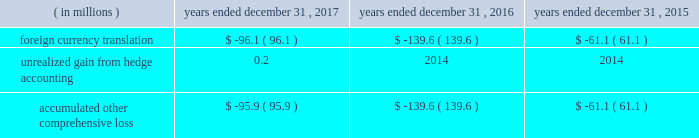Table of contents cdw corporation and subsidiaries method or straight-line method , as applicable .
The company classifies deferred financing costs as a direct deduction from the carrying value of the long-term debt liability on the consolidated balance sheets , except for deferred financing costs associated with revolving credit facilities which are presented as an asset , within other assets on the consolidated balance sheets .
Derivative instruments the company has interest rate cap agreements for the purpose of hedging its exposure to fluctuations in interest rates .
The interest rate cap agreements are designated as cash flow hedges of interest rate risk and recorded at fair value in other assets on the consolidated balance sheets .
The gain or loss on the derivative instruments is reported as a component of accumulated other comprehensive loss until reclassified to interest expense in the same period the hedge transaction affects earnings .
Fair value measurements fair value is defined under gaap as the price that would be received to sell an asset or paid to transfer a liability in an orderly transaction between market participants at the measurement date .
A fair value hierarchy has been established for valuation inputs to prioritize the inputs into three levels based on the extent to which inputs used in measuring fair value are observable in the market .
Each fair value measurement is reported in one of the three levels which is determined by the lowest level input that is significant to the fair value measurement in its entirety .
These levels are : level 1 2013 observable inputs such as quoted prices for identical instruments traded in active markets .
Level 2 2013 inputs are based on quoted prices for similar instruments in active markets , quoted prices for identical or similar instruments in markets that are not active and model-based valuation techniques for which all significant assumptions are observable in the market or can be corroborated by observable market data for substantially the full term of the assets or liabilities .
Level 3 2013 inputs are generally unobservable and typically reflect management 2019s estimates of assumptions that market participants would use in pricing the asset or liability .
The fair values are therefore determined using model-based techniques that include option pricing models , discounted cash flow models and similar techniques .
Accumulated other comprehensive loss the components of accumulated other comprehensive loss included in stockholders 2019 equity are as follows: .
Revenue recognition the company is a primary distribution channel for a large group of vendors and suppliers , including original equipment manufacturers ( 201coems 201d ) , software publishers , wholesale distributors and cloud providers .
The company records revenue from sales transactions when title and risk of loss are passed to the customer , there is persuasive evidence of an arrangement for sale , delivery has occurred and/or services have been rendered , the sales price is fixed or determinable , and collectability is reasonably assured .
The company 2019s shipping terms typically specify f.o.b .
Destination , at which time title and risk of loss have passed to the customer .
Revenues from the sales of hardware products and software licenses are generally recognized on a gross basis with the selling price to the customer recorded as sales and the acquisition cost of the product recorded as cost of sales .
These items can be delivered to customers in a variety of ways , including ( i ) as physical product shipped from the company 2019s warehouse , ( ii ) via drop-shipment by the vendor or supplier , or ( iii ) via electronic delivery for software licenses .
At the time of sale , the company records an estimate for sales returns and allowances based on historical experience .
The company 2019s vendor partners warrant most of the products the company sells .
The company leverages drop-shipment arrangements with many of its vendors and suppliers to deliver products to its customers without having to physically hold the inventory at its warehouses , thereby increasing efficiency and reducing .
What was the greatest foreign currency translation loss , in millions? 
Computations: table_min(foreign currency translation, none)
Answer: -139.6. 